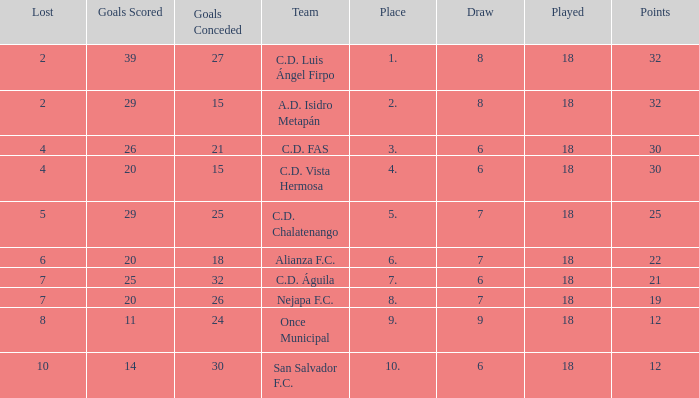What is the total number for a place with points smaller than 12? 0.0. 